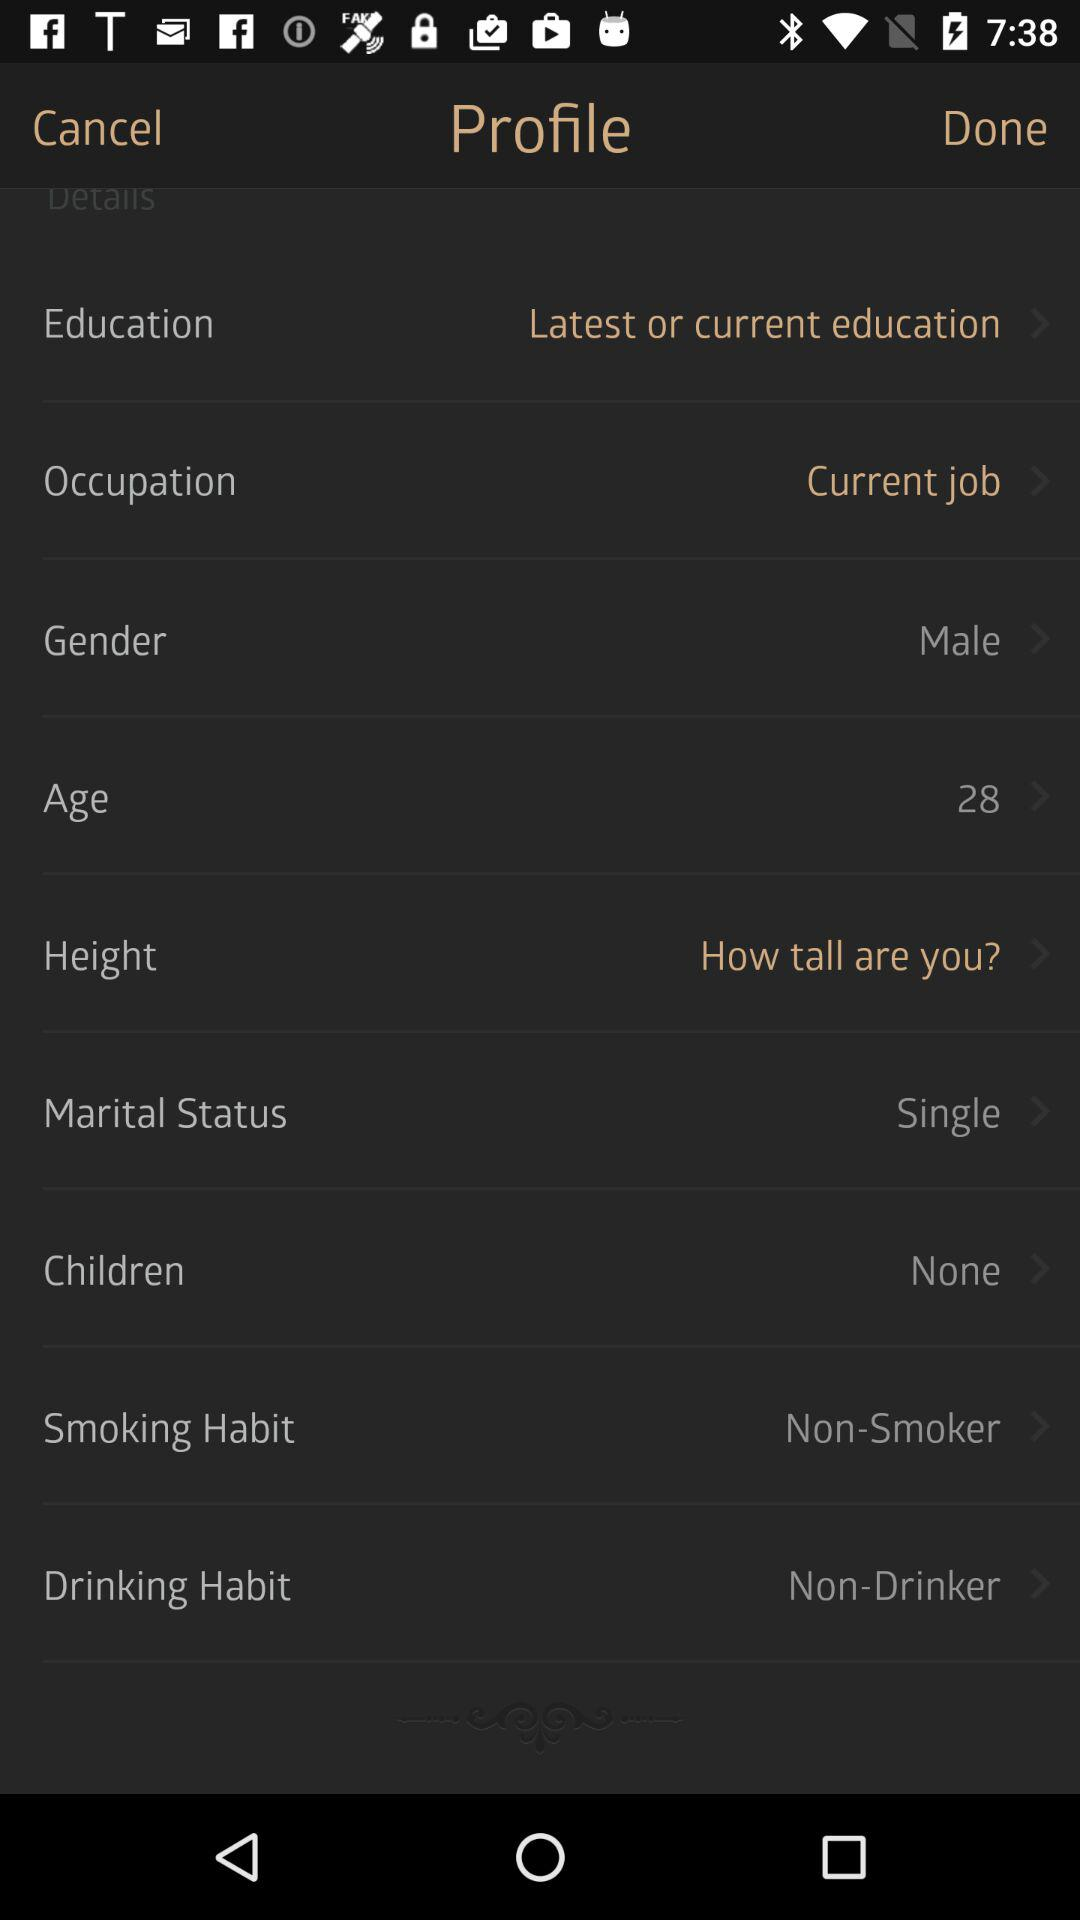Are there any children? There are no children. 